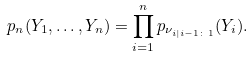<formula> <loc_0><loc_0><loc_500><loc_500>p _ { n } ( Y _ { 1 } , \dots , Y _ { n } ) = \prod _ { i = 1 } ^ { n } p _ { \nu _ { i | i - 1 \colon 1 } } ( Y _ { i } ) .</formula> 